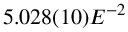Convert formula to latex. <formula><loc_0><loc_0><loc_500><loc_500>5 . 0 2 8 ( 1 0 ) E ^ { - 2 }</formula> 